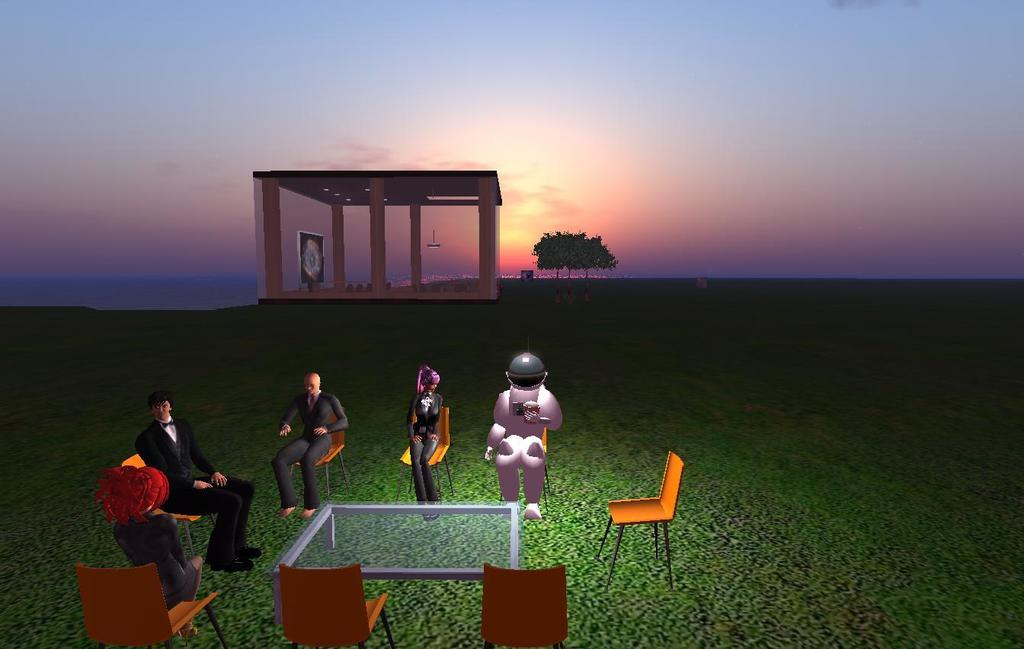What type of images are present in the image? There are animated images in the image. What are the animated images doing in the image? The animated images are sitting on chairs. Where are the chairs located in the image? The chairs are on grass land. What can be seen in the background of the image? There is a building in the background of the image, and a tree behind the building. What is visible above the building in the image? The sky is visible above the building. What type of support can be seen for the snakes in the image? There are no snakes present in the image, so there is no support for them. What role does the minister play in the image? There is no minister present in the image, so there is no role for them. 